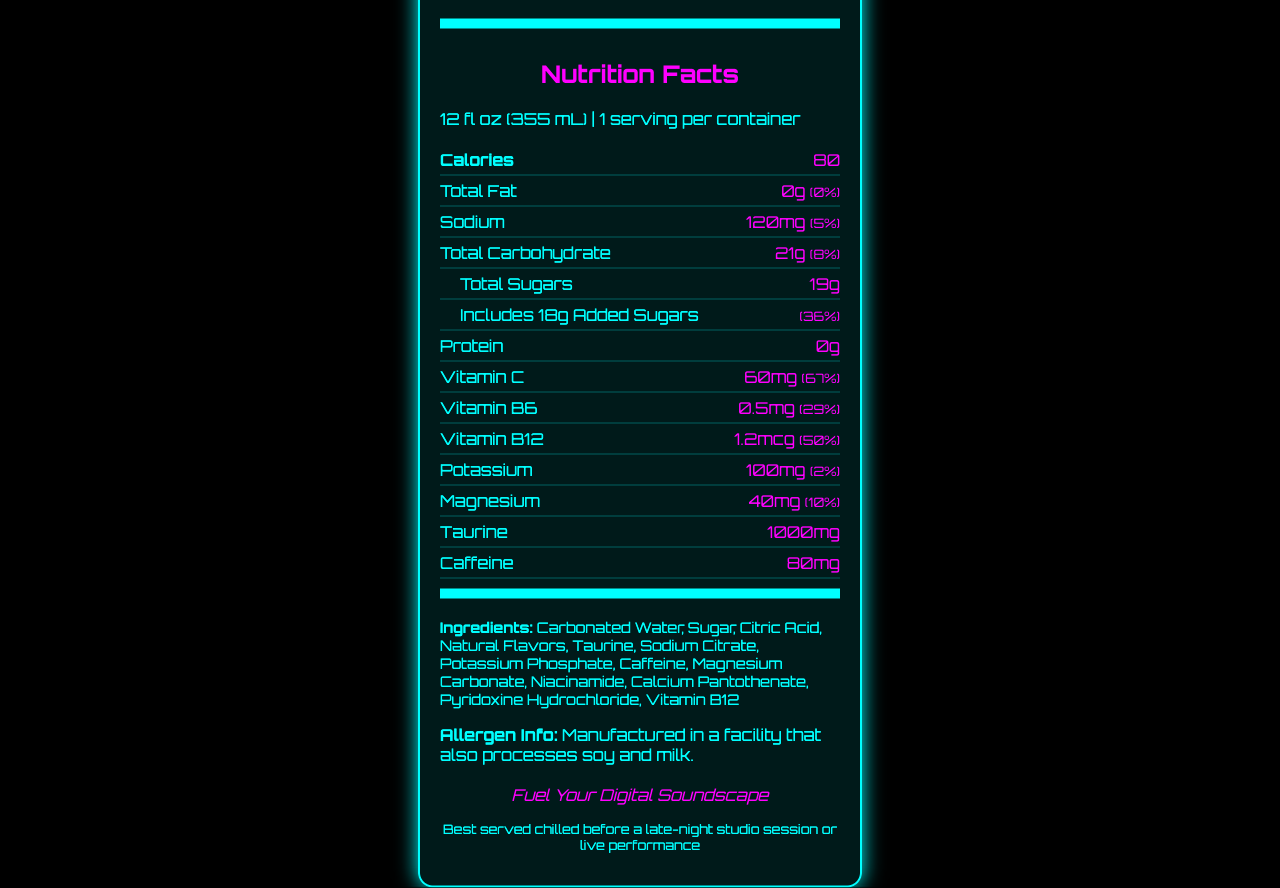how many calories are in a serving? The Nutrition Facts label indicates there are 80 calories in one serving of SynthBoost Electro-Fusion.
Answer: 80 how much sodium does the drink contain? According to the Nutrition Facts, the drink contains 120mg of sodium.
Answer: 120mg what is the daily value percentage of added sugars? The label shows that added sugars make up 36% of the daily value.
Answer: 36% is the drink suitable for someone monitoring their fat intake? The label shows that the drink contains 0g of total fat, which is 0% of the daily value, making it suitable for someone watching their fat intake.
Answer: Yes how much caffeine is in the drink? The nutrition label states that the drink contains 80mg of caffeine.
Answer: 80mg how much vitamin C is in the drink? A. 60mg B. 40mg C. 80mg D. 20mg The label lists 60mg of vitamin C, which is 67% of the daily value.
Answer: A how many grams of total carbohydrate does the drink contain? 1) 10g 2) 21g 3) 15g The label indicates that the drink contains 21g of total carbohydrates, making option 2 correct.
Answer: 2) 21g is the drink recommended for vegans? The document does not mention whether it is vegan-friendly or if the manufacturing process involves animal products.
Answer: Not enough information how many grams of protein are in the drink? The label clearly states that the drink contains 0g of protein.
Answer: 0g summarize the main points of the document The document presents a detailed nutritional profile of the energy drink, along with its ingredients and allergen information, promotional elements, and suggested usage.
Answer: The document provides the Nutrition Facts for "SynthBoost Electro-Fusion," a synth-inspired energy drink. It includes serving size, calories, and the amounts and daily values of various nutrients like sodium, carbohydrates, sugars, vitamins, and minerals. The drink contains notable ingredients like taurine and caffeine and is manufactured in a facility processing soy and milk. The marketing tagline is "Fuel Your Digital Soundscape," suggesting its usage in creative and performance settings. is this drink high in Magnesium? The drink contains 40mg of magnesium, which is 10% of the daily value. This amount does not qualify as "high" in magnesium.
Answer: No does the drink contain any artificial flavors? The ingredients list mentions "Natural Flavors," indicating no artificial flavors are used.
Answer: No can I find the production date on this document? The document does not provide any information related to the production date.
Answer: No 